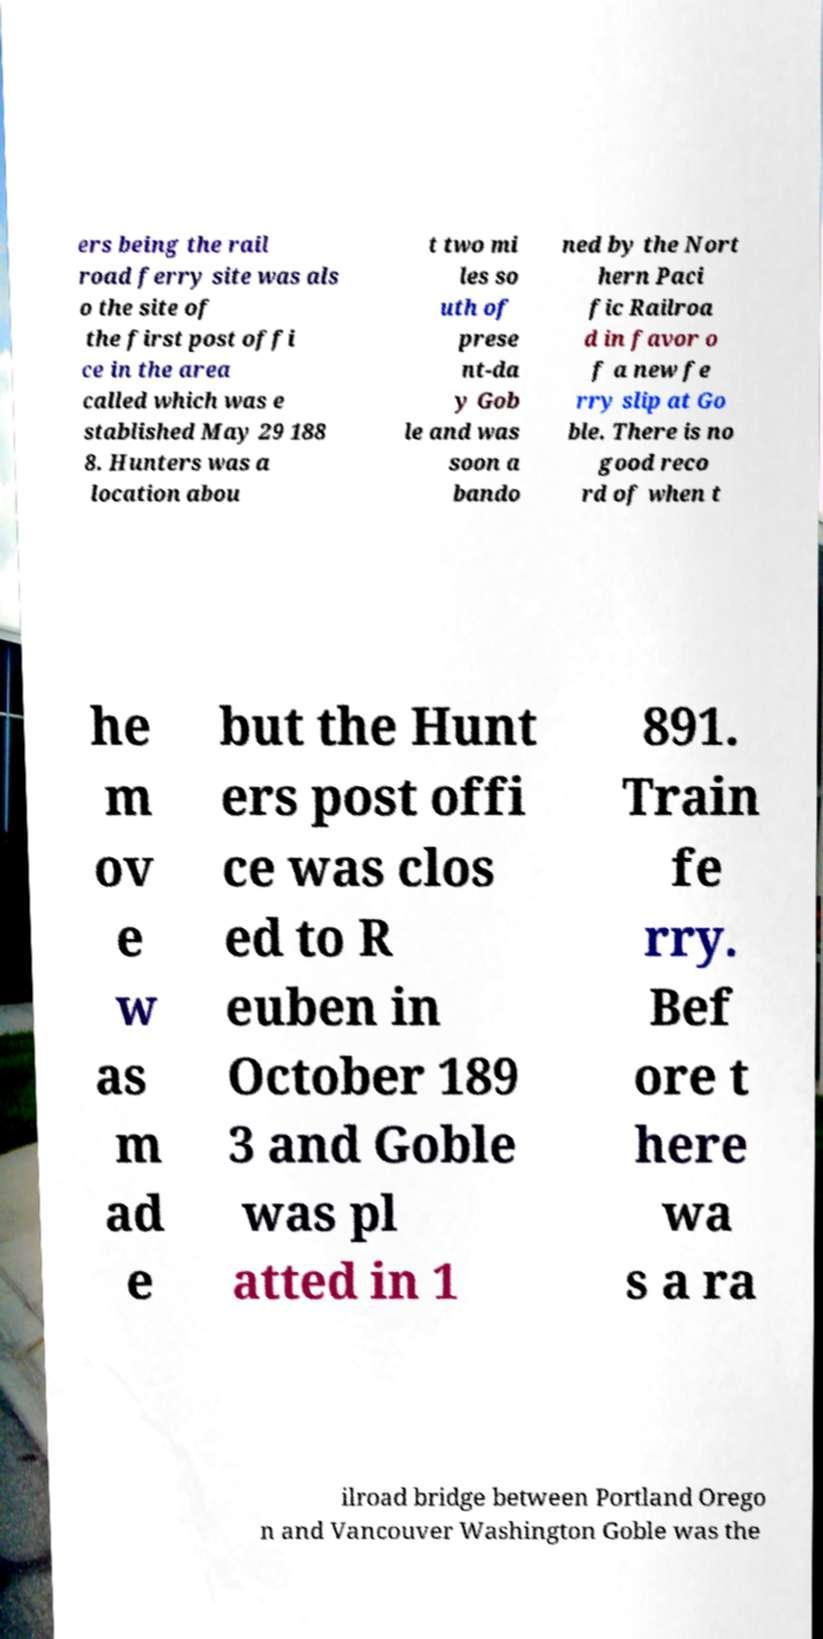For documentation purposes, I need the text within this image transcribed. Could you provide that? ers being the rail road ferry site was als o the site of the first post offi ce in the area called which was e stablished May 29 188 8. Hunters was a location abou t two mi les so uth of prese nt-da y Gob le and was soon a bando ned by the Nort hern Paci fic Railroa d in favor o f a new fe rry slip at Go ble. There is no good reco rd of when t he m ov e w as m ad e but the Hunt ers post offi ce was clos ed to R euben in October 189 3 and Goble was pl atted in 1 891. Train fe rry. Bef ore t here wa s a ra ilroad bridge between Portland Orego n and Vancouver Washington Goble was the 